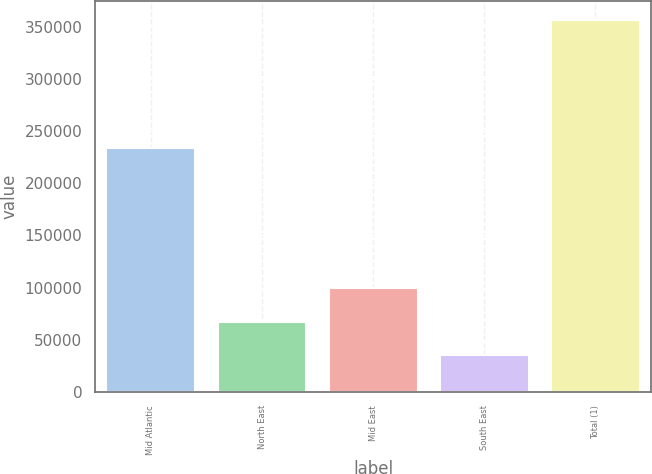Convert chart. <chart><loc_0><loc_0><loc_500><loc_500><bar_chart><fcel>Mid Atlantic<fcel>North East<fcel>Mid East<fcel>South East<fcel>Total (1)<nl><fcel>233458<fcel>67520.1<fcel>99630.2<fcel>35410<fcel>356511<nl></chart> 